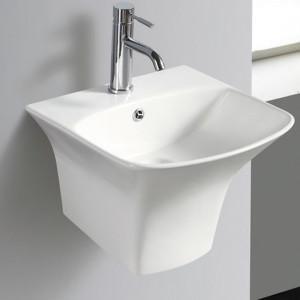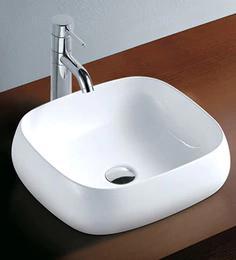The first image is the image on the left, the second image is the image on the right. Examine the images to the left and right. Is the description "Two white sinks have center faucets and are mounted so the outer sink is shown." accurate? Answer yes or no. Yes. 